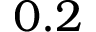<formula> <loc_0><loc_0><loc_500><loc_500>0 . 2</formula> 